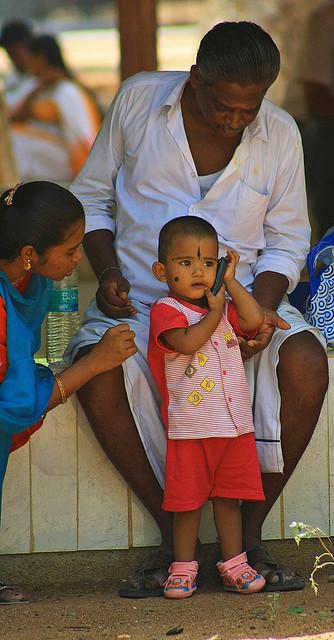What type of phone is being used?

Choices:
A) cellular
B) pay
C) landline
D) rotary cellular 